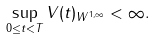<formula> <loc_0><loc_0><loc_500><loc_500>\sup _ { 0 \leq t < T } \| V ( t ) \| _ { W ^ { 1 , \infty } } < \infty .</formula> 